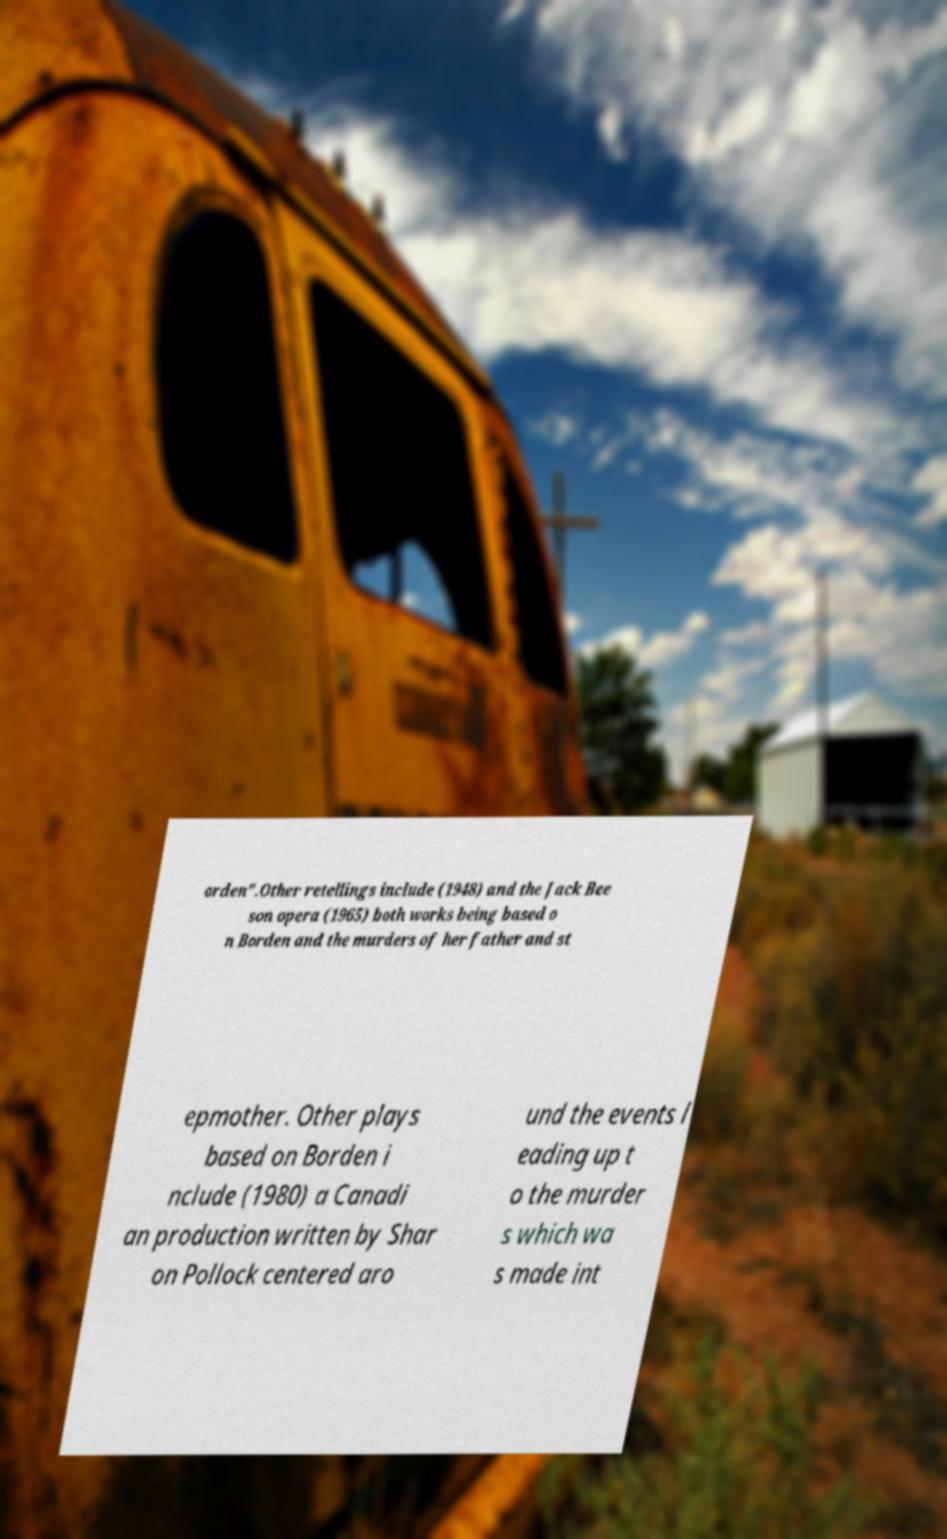What messages or text are displayed in this image? I need them in a readable, typed format. orden".Other retellings include (1948) and the Jack Bee son opera (1965) both works being based o n Borden and the murders of her father and st epmother. Other plays based on Borden i nclude (1980) a Canadi an production written by Shar on Pollock centered aro und the events l eading up t o the murder s which wa s made int 